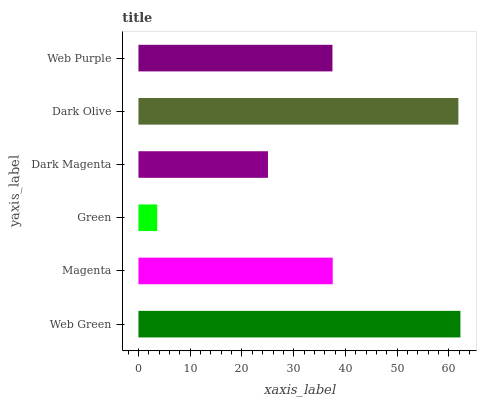Is Green the minimum?
Answer yes or no. Yes. Is Web Green the maximum?
Answer yes or no. Yes. Is Magenta the minimum?
Answer yes or no. No. Is Magenta the maximum?
Answer yes or no. No. Is Web Green greater than Magenta?
Answer yes or no. Yes. Is Magenta less than Web Green?
Answer yes or no. Yes. Is Magenta greater than Web Green?
Answer yes or no. No. Is Web Green less than Magenta?
Answer yes or no. No. Is Magenta the high median?
Answer yes or no. Yes. Is Web Purple the low median?
Answer yes or no. Yes. Is Web Purple the high median?
Answer yes or no. No. Is Dark Magenta the low median?
Answer yes or no. No. 